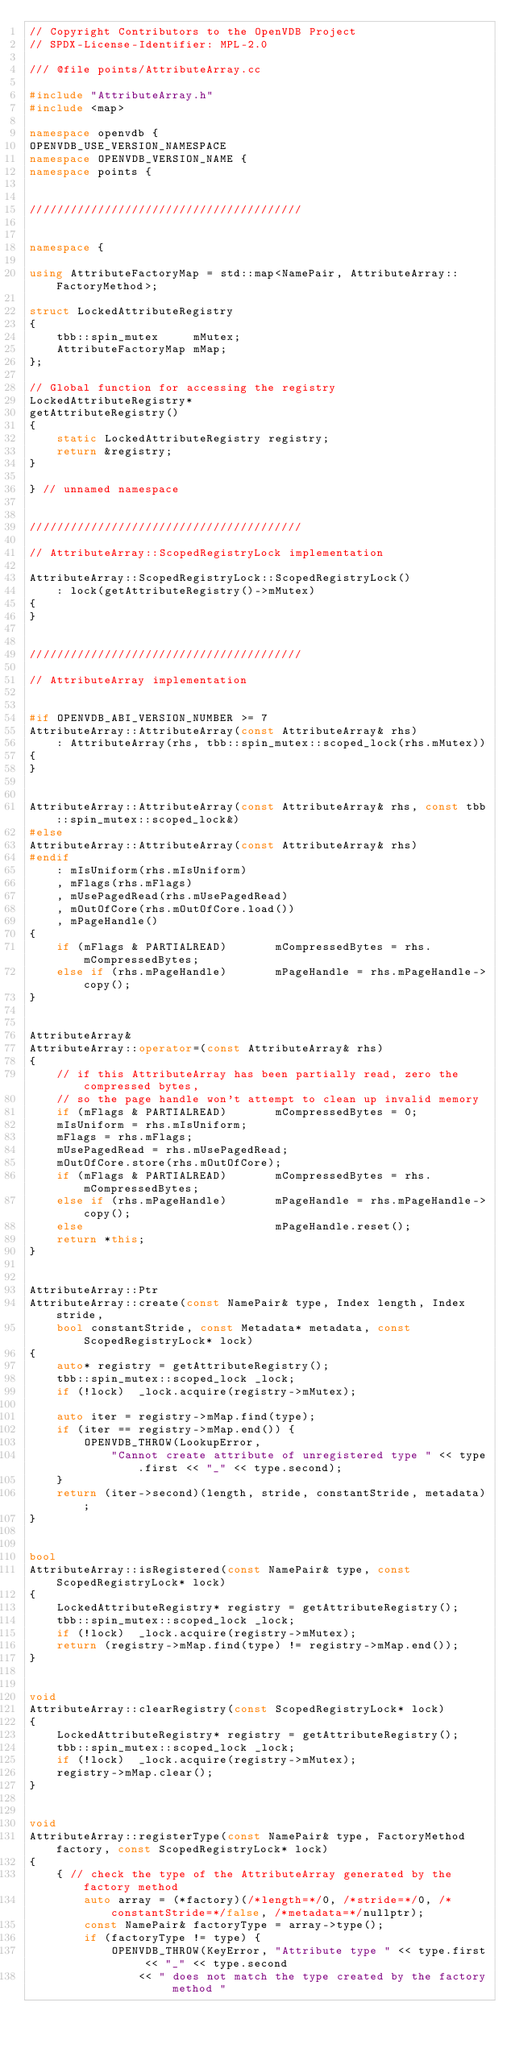<code> <loc_0><loc_0><loc_500><loc_500><_C++_>// Copyright Contributors to the OpenVDB Project
// SPDX-License-Identifier: MPL-2.0

/// @file points/AttributeArray.cc

#include "AttributeArray.h"
#include <map>

namespace openvdb {
OPENVDB_USE_VERSION_NAMESPACE
namespace OPENVDB_VERSION_NAME {
namespace points {


////////////////////////////////////////


namespace {

using AttributeFactoryMap = std::map<NamePair, AttributeArray::FactoryMethod>;

struct LockedAttributeRegistry
{
    tbb::spin_mutex     mMutex;
    AttributeFactoryMap mMap;
};

// Global function for accessing the registry
LockedAttributeRegistry*
getAttributeRegistry()
{
    static LockedAttributeRegistry registry;
    return &registry;
}

} // unnamed namespace


////////////////////////////////////////

// AttributeArray::ScopedRegistryLock implementation

AttributeArray::ScopedRegistryLock::ScopedRegistryLock()
    : lock(getAttributeRegistry()->mMutex)
{
}


////////////////////////////////////////

// AttributeArray implementation


#if OPENVDB_ABI_VERSION_NUMBER >= 7
AttributeArray::AttributeArray(const AttributeArray& rhs)
    : AttributeArray(rhs, tbb::spin_mutex::scoped_lock(rhs.mMutex))
{
}


AttributeArray::AttributeArray(const AttributeArray& rhs, const tbb::spin_mutex::scoped_lock&)
#else
AttributeArray::AttributeArray(const AttributeArray& rhs)
#endif
    : mIsUniform(rhs.mIsUniform)
    , mFlags(rhs.mFlags)
    , mUsePagedRead(rhs.mUsePagedRead)
    , mOutOfCore(rhs.mOutOfCore.load())
    , mPageHandle()
{
    if (mFlags & PARTIALREAD)       mCompressedBytes = rhs.mCompressedBytes;
    else if (rhs.mPageHandle)       mPageHandle = rhs.mPageHandle->copy();
}


AttributeArray&
AttributeArray::operator=(const AttributeArray& rhs)
{
    // if this AttributeArray has been partially read, zero the compressed bytes,
    // so the page handle won't attempt to clean up invalid memory
    if (mFlags & PARTIALREAD)       mCompressedBytes = 0;
    mIsUniform = rhs.mIsUniform;
    mFlags = rhs.mFlags;
    mUsePagedRead = rhs.mUsePagedRead;
    mOutOfCore.store(rhs.mOutOfCore);
    if (mFlags & PARTIALREAD)       mCompressedBytes = rhs.mCompressedBytes;
    else if (rhs.mPageHandle)       mPageHandle = rhs.mPageHandle->copy();
    else                            mPageHandle.reset();
    return *this;
}


AttributeArray::Ptr
AttributeArray::create(const NamePair& type, Index length, Index stride,
    bool constantStride, const Metadata* metadata, const ScopedRegistryLock* lock)
{
    auto* registry = getAttributeRegistry();
    tbb::spin_mutex::scoped_lock _lock;
    if (!lock)  _lock.acquire(registry->mMutex);

    auto iter = registry->mMap.find(type);
    if (iter == registry->mMap.end()) {
        OPENVDB_THROW(LookupError,
            "Cannot create attribute of unregistered type " << type.first << "_" << type.second);
    }
    return (iter->second)(length, stride, constantStride, metadata);
}


bool
AttributeArray::isRegistered(const NamePair& type, const ScopedRegistryLock* lock)
{
    LockedAttributeRegistry* registry = getAttributeRegistry();
    tbb::spin_mutex::scoped_lock _lock;
    if (!lock)  _lock.acquire(registry->mMutex);
    return (registry->mMap.find(type) != registry->mMap.end());
}


void
AttributeArray::clearRegistry(const ScopedRegistryLock* lock)
{
    LockedAttributeRegistry* registry = getAttributeRegistry();
    tbb::spin_mutex::scoped_lock _lock;
    if (!lock)  _lock.acquire(registry->mMutex);
    registry->mMap.clear();
}


void
AttributeArray::registerType(const NamePair& type, FactoryMethod factory, const ScopedRegistryLock* lock)
{
    { // check the type of the AttributeArray generated by the factory method
        auto array = (*factory)(/*length=*/0, /*stride=*/0, /*constantStride=*/false, /*metadata=*/nullptr);
        const NamePair& factoryType = array->type();
        if (factoryType != type) {
            OPENVDB_THROW(KeyError, "Attribute type " << type.first << "_" << type.second
                << " does not match the type created by the factory method "</code> 